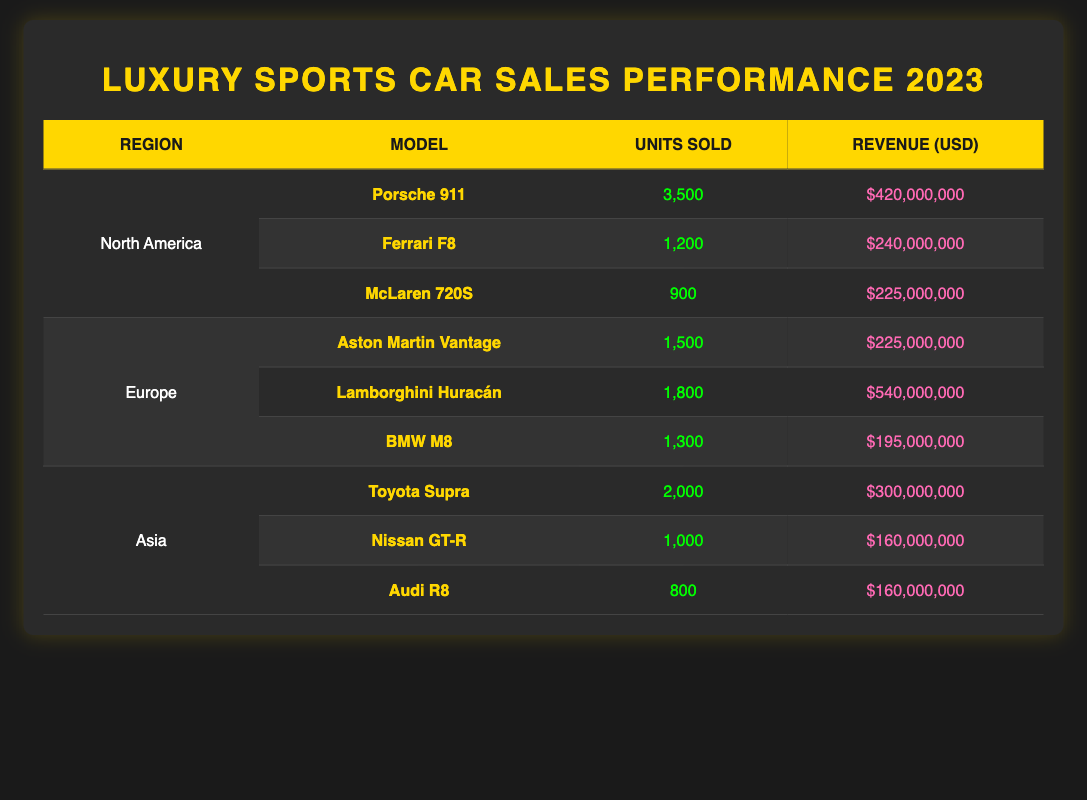What is the total revenue generated by luxury sports cars in North America? To find the total revenue in North America, add the revenues from all models sold in that region: $420,000,000 (Porsche 911) + $240,000,000 (Ferrari F8) + $225,000,000 (McLaren 720S) = $885,000,000.
Answer: $885,000,000 Which model sold the most units in Europe? In Europe, the models listed are Aston Martin Vantage with 1,500 units, Lamborghini Huracán with 1,800 units, and BMW M8 with 1,300 units. The Lamborghini Huracán sold the most units.
Answer: Lamborghini Huracán Is the total number of units sold in Asia greater than that in North America? For Asia, the total units sold are: 2,000 (Toyota Supra) + 1,000 (Nissan GT-R) + 800 (Audi R8) = 3,800. For North America, the total units sold are: 3,500 (Porsche 911) + 1,200 (Ferrari F8) + 900 (McLaren 720S) = 5,600. Since 3,800 is not greater than 5,600, the answer is no.
Answer: No What is the average revenue for luxury sports cars in Europe? The total revenue from Europe is $225,000,000 (Aston Martin Vantage) + $540,000,000 (Lamborghini Huracán) + $195,000,000 (BMW M8) = $960,000,000. There are 3 models, so the average revenue is $960,000,000 / 3 = $320,000,000.
Answer: $320,000,000 Did the Nissan GT-R generate more revenue than the BMW M8? The revenue for Nissan GT-R is $160,000,000 and for BMW M8 it is $195,000,000. Since $160,000,000 is less than $195,000,000, the answer is no.
Answer: No What is the difference in units sold between the Lamborghini Huracán and the Porsche 911? The Lamborghini Huracán sold 1,800 units, and the Porsche 911 sold 3,500 units. The difference is calculated as 3,500 - 1,800 = 1,700 units.
Answer: 1,700 What percentage of the total units sold in North America does the Porsche 911 represent? The total units sold in North America are 3,500 (Porsche 911) + 1,200 (Ferrari F8) + 900 (McLaren 720S) = 5,600. The percentage for Porsche 911 is (3,500 / 5,600) * 100 = 62.5%.
Answer: 62.5% Which region had the model with the highest revenue? The Lamborghini Huracán in Europe generated the highest revenue of $540,000,000 compared to other models in all regions.
Answer: Europe How many units of the Audi R8 were sold compared to the Aston Martin Vantage? The Audi R8 sold 800 units and the Aston Martin Vantage sold 1,500 units. The comparison shows that Aston Martin Vantage sold 700 more units than Audi R8.
Answer: 700 more units 